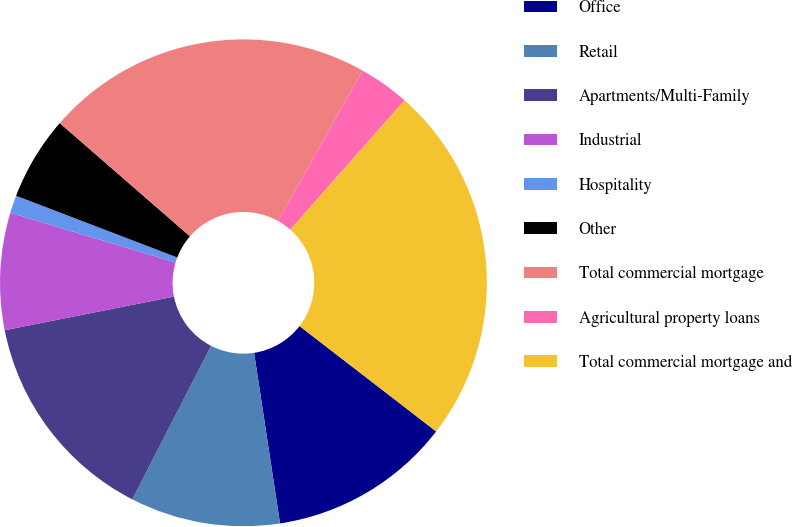<chart> <loc_0><loc_0><loc_500><loc_500><pie_chart><fcel>Office<fcel>Retail<fcel>Apartments/Multi-Family<fcel>Industrial<fcel>Hospitality<fcel>Other<fcel>Total commercial mortgage<fcel>Agricultural property loans<fcel>Total commercial mortgage and<nl><fcel>12.14%<fcel>9.95%<fcel>14.33%<fcel>7.76%<fcel>1.18%<fcel>5.57%<fcel>21.75%<fcel>3.37%<fcel>23.94%<nl></chart> 